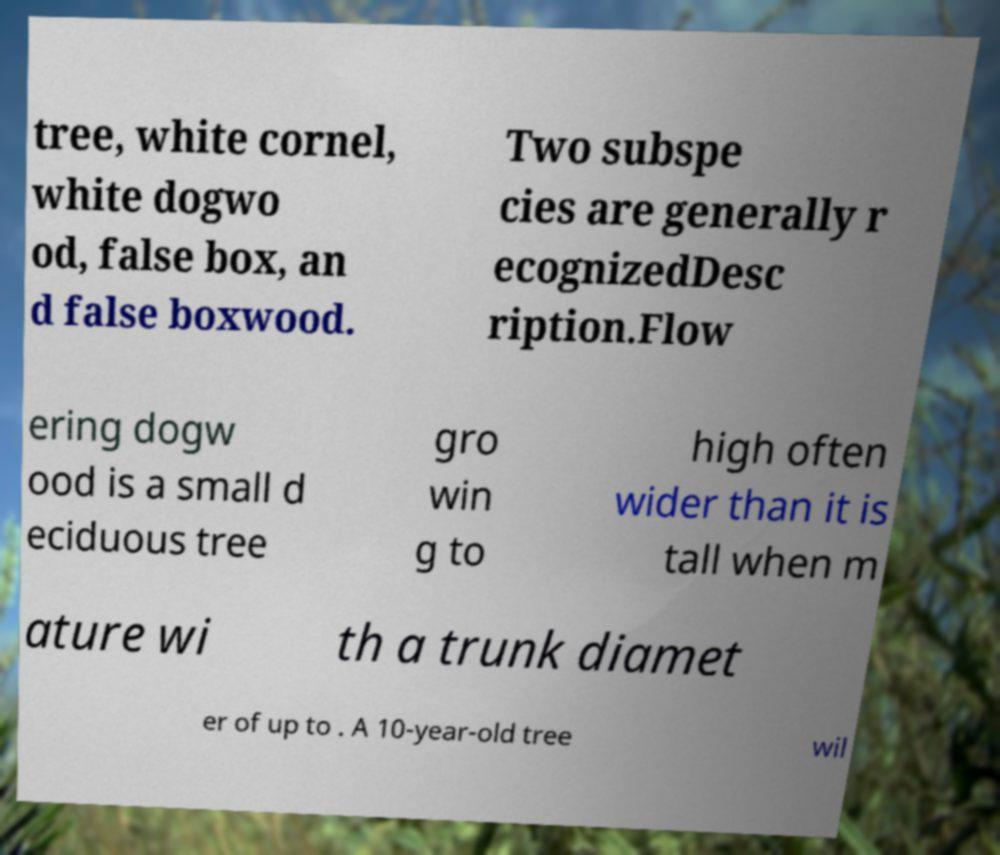I need the written content from this picture converted into text. Can you do that? tree, white cornel, white dogwo od, false box, an d false boxwood. Two subspe cies are generally r ecognizedDesc ription.Flow ering dogw ood is a small d eciduous tree gro win g to high often wider than it is tall when m ature wi th a trunk diamet er of up to . A 10-year-old tree wil 